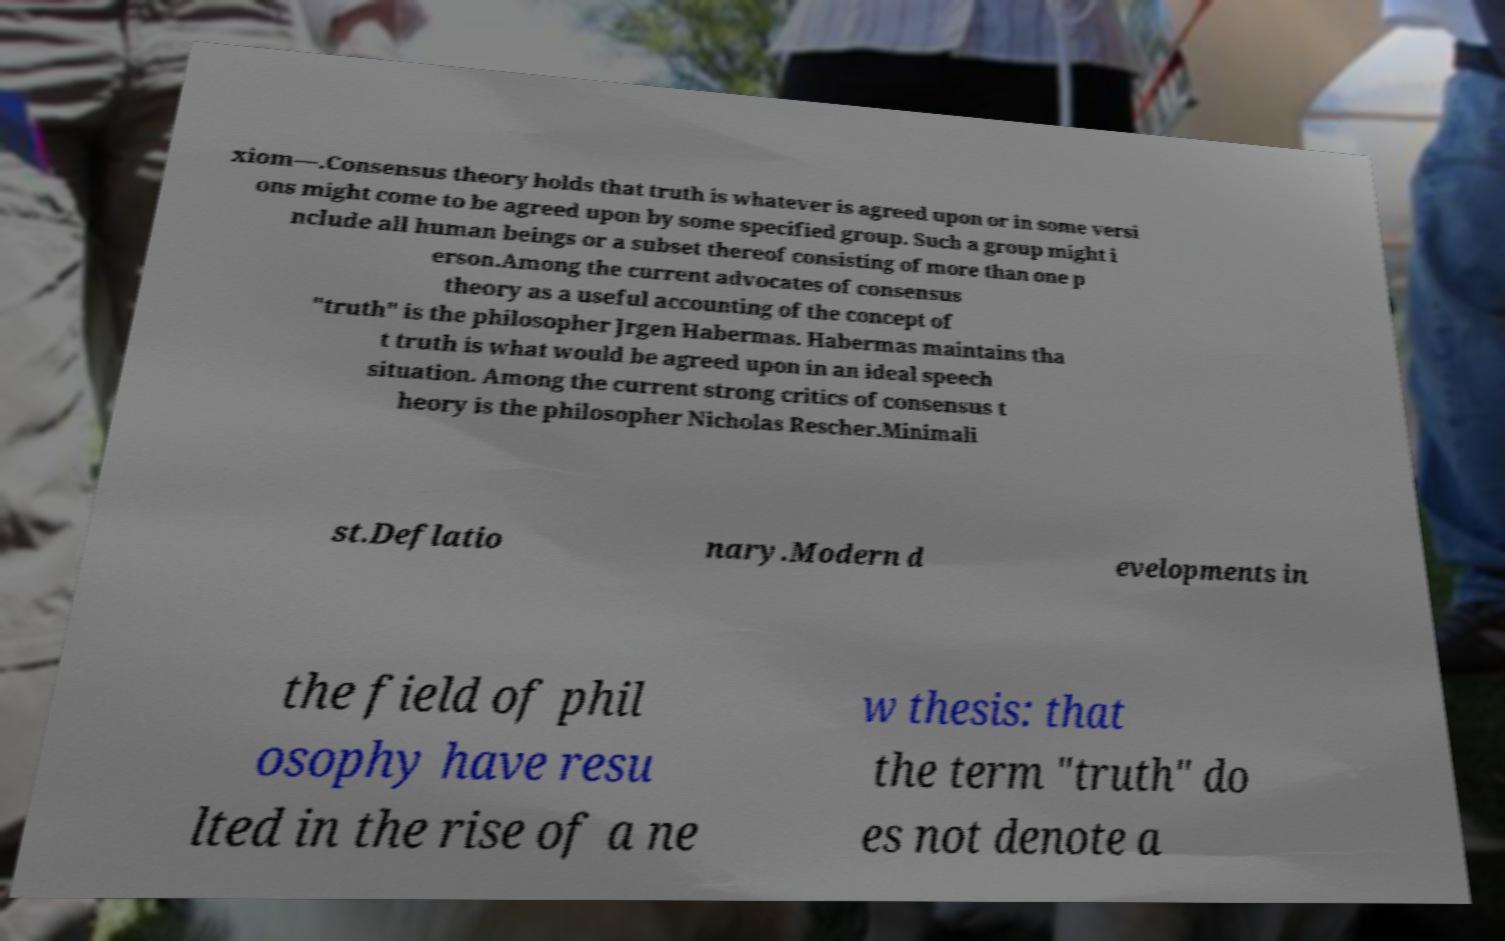Please read and relay the text visible in this image. What does it say? xiom—.Consensus theory holds that truth is whatever is agreed upon or in some versi ons might come to be agreed upon by some specified group. Such a group might i nclude all human beings or a subset thereof consisting of more than one p erson.Among the current advocates of consensus theory as a useful accounting of the concept of "truth" is the philosopher Jrgen Habermas. Habermas maintains tha t truth is what would be agreed upon in an ideal speech situation. Among the current strong critics of consensus t heory is the philosopher Nicholas Rescher.Minimali st.Deflatio nary.Modern d evelopments in the field of phil osophy have resu lted in the rise of a ne w thesis: that the term "truth" do es not denote a 